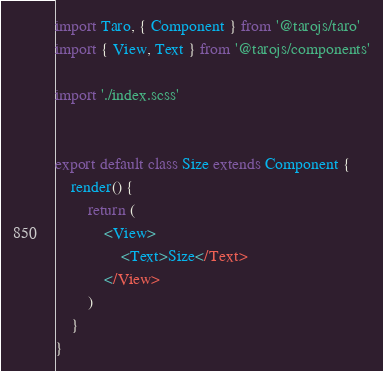<code> <loc_0><loc_0><loc_500><loc_500><_JavaScript_>import Taro, { Component } from '@tarojs/taro'
import { View, Text } from '@tarojs/components'

import './index.scss'


export default class Size extends Component {
    render() {
        return (
            <View>
                <Text>Size</Text>
            </View>
        )
    }
}</code> 